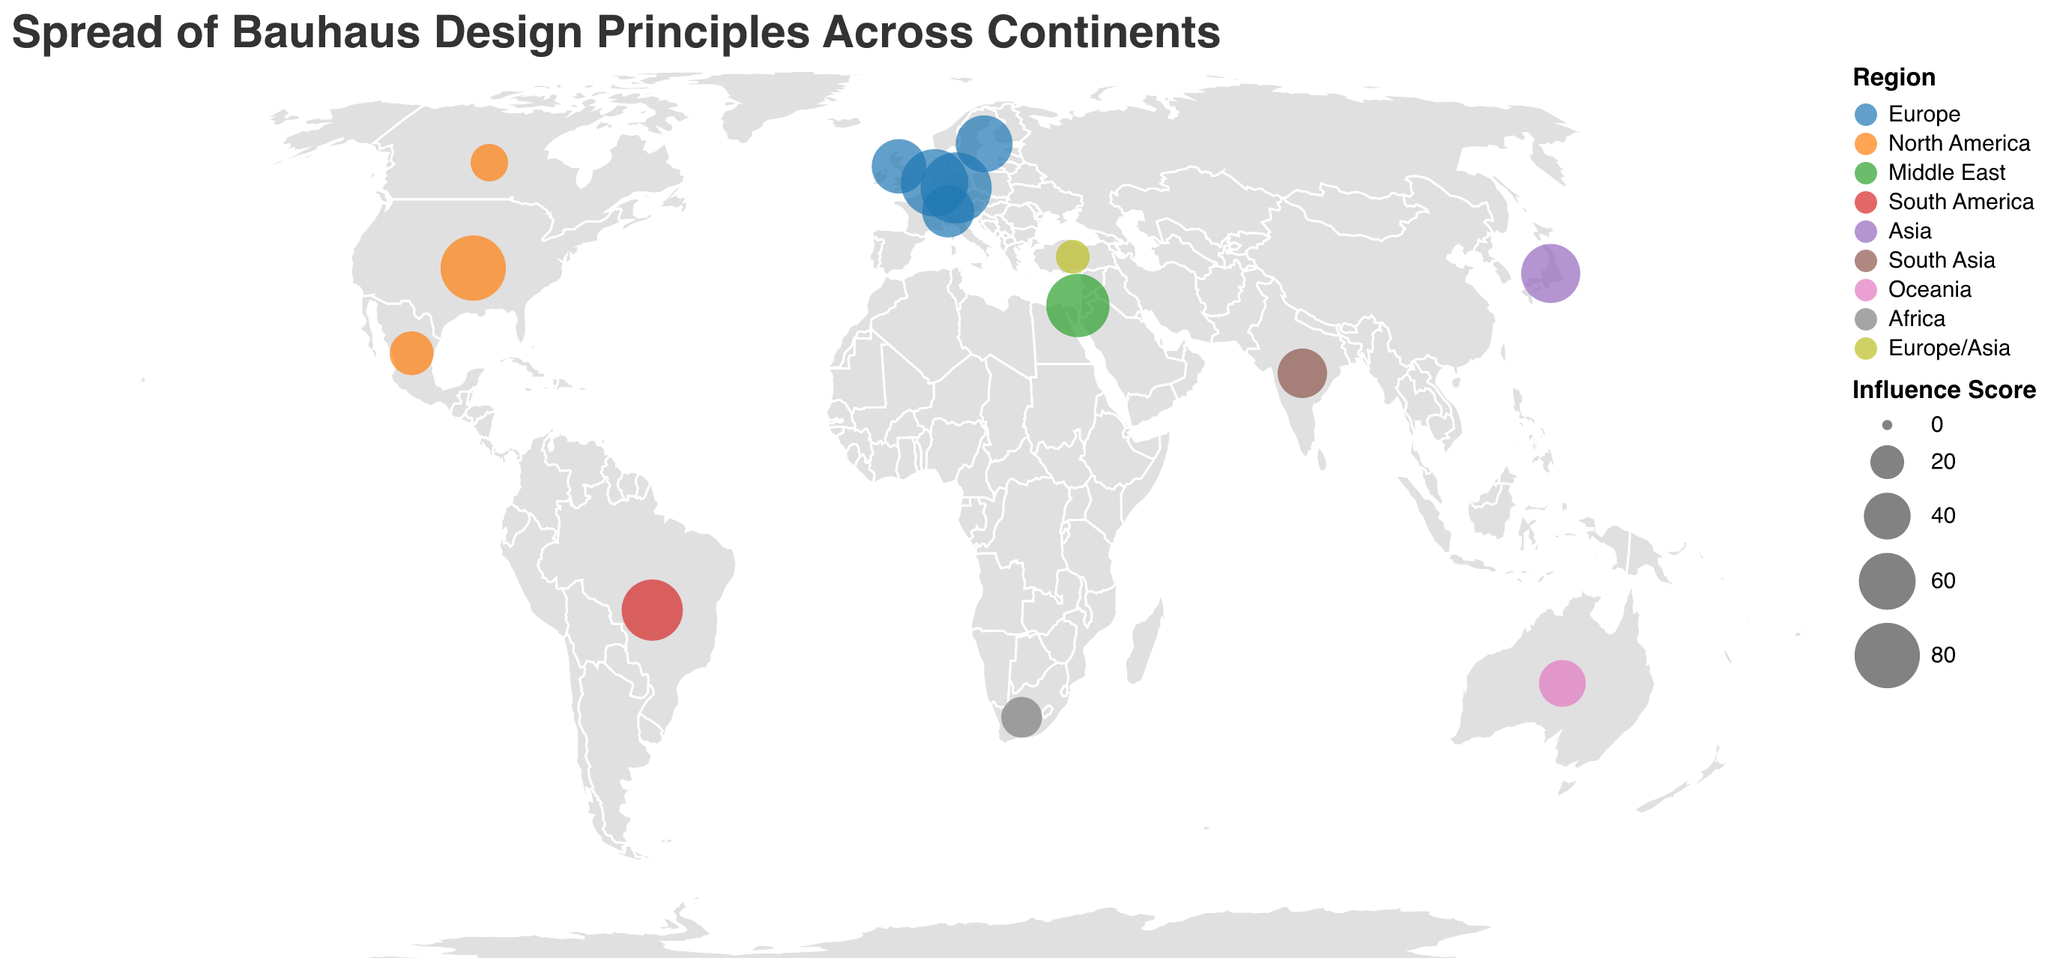Which country in Europe has the highest influence score according to the plot? The highest influence score in Europe can be identified by looking for the largest circle, colored in blue, within the boundaries of Europe. Germany has the largest blue circle.
Answer: Germany Which region has the lowest number of countries represented on the plot? To find the region with the lowest number of countries, count the number of circles in each region identified by the distinct colors. Oceania has only one country represented.
Answer: Oceania What is the influence score of the institution in South Africa? Locate South Africa on the map and identify the circle within its geographical boundary. The tooltip or legend reveals the influence score. South Africa has an influence score of 30.
Answer: 30 Which two countries in North America are shown on the plot? Identify the region of North America represented by distinct colors (such as shades of orange) and locate the countries within its boundaries. The two countries in North America are the United States and Mexico.
Answer: United States and Mexico Of the countries listed, which has the smallest influence score, and what is it? Identify the smallest circle on the map and match it to the corresponding country in the tooltip or legend. The smallest influence score is associated with Turkey, with a score of 20.
Answer: Turkey, 20 What is the average influence score of institutions in European countries? Identify all the influence scores of European countries and compute the average. Scores: 95 (Germany), 85 (Netherlands), 60 (Sweden), 55 (United Kingdom), 50 (Switzerland), 20 (Turkey). (95 + 85 + 60 + 55 + 50 + 20) / 6 = 365 / 6 ≈ 61
Answer: 61 Which institution in the Middle East has an influence score of 75? Locate the single representation in the Middle East and refer to the tooltip or legend for details. The institution with a score of 75 in the Middle East is Bezalel Academy of Arts and Design in Israel.
Answer: Bezalel Academy of Arts and Design How does the influence score of the institution in Japan compare to that of the institution in India? Compare the influence score values for Japan and India found on the map. Japan's institution has a score of 65, while India's institution has a score of 45. Japan's score is higher.
Answer: Japan has a higher score What are the notable institutions in the United States and Canada, and how do their influence scores differ? Refer to the tooltip or legend for the institutions in the United States and Canada and note their influence scores. United States: IIT Institute of Design with a score of 80; Canada: OCAD University with a score of 25. The difference is 80 - 25 = 55.
Answer: IIT Institute of Design (USA) and OCAD University (Canada), difference: 55 